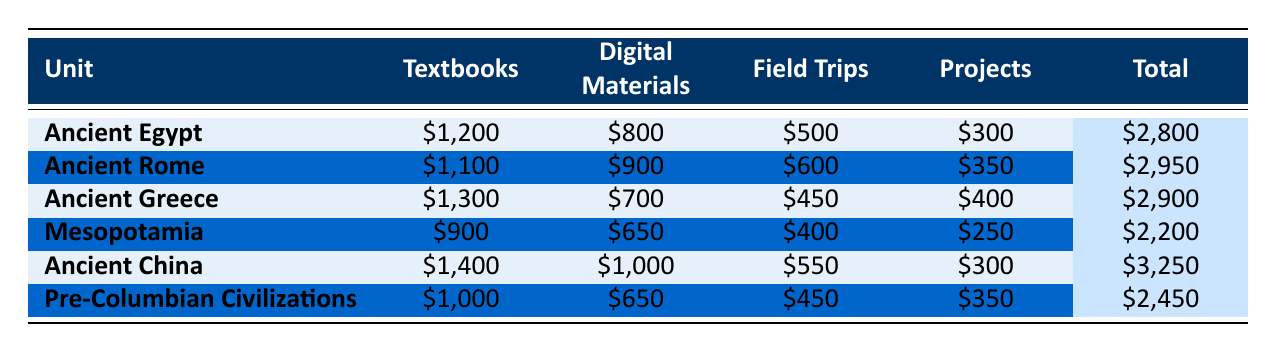What is the total budget allocated for Ancient Egypt? The total budget for Ancient Egypt is clearly stated in the table under the 'Total' column, which shows \$2,800.
Answer: \$2,800 Which unit has the highest budget allocation? By comparing the 'Total' values for each unit, Ancient China has the highest allocation of \$3,250.
Answer: Ancient China What is the total budget for textbooks across all units? To find the total for textbooks, sum the values in the 'Textbooks' column: 1200 + 1100 + 1300 + 900 + 1400 + 1000 = 6200.
Answer: \$6,200 Is the budget for Ancient Rome larger than that for Ancient Greece? By comparing the total budgets, Ancient Rome has \$2,950 while Ancient Greece has \$2,900, indicating that Ancient Rome's budget is larger.
Answer: Yes What is the difference in total budget between Ancient China and Mesopotamia? Subtract the total budget of Mesopotamia (\$2,200) from that of Ancient China (\$3,250): 3250 - 2200 = 1050.
Answer: \$1,050 What percentage of the total budget for Ancient Greece is allocated to digital materials? Calculate the percentage allocated to digital materials by taking the value for digital materials (\$700) and dividing by the total budget (\$2,900), then multiplying by 100: (700 / 2900) * 100 ≈ 24.14%.
Answer: 24.14% If the field trip budget for each unit were reduced by \$100, what would be the new total budget for Ancient Egypt? The original total budget for Ancient Egypt is \$2,800. Reducing the field trip budget by \$100 means subtracting that from the total: 2800 - 100 = 2700.
Answer: \$2,700 What is the average total budget allocated across all units? Add all total budgets: 2800 + 2950 + 2900 + 2200 + 3250 + 2450 = 16550, then divide by the number of units (6): 16550 / 6 = 2758.33.
Answer: \$2,758.33 Is the total budget for Pre-Columbian Civilizations lower than that for Mesopotamia? Comparing the total budgets, Pre-Columbian Civilizations has \$2,450 and Mesopotamia has \$2,200. Therefore, Pre-Columbian Civilizations is higher.
Answer: No Which two units have the closest total budget allocations? By examining the total budgets, Ancient Greece has \$2,900 and Ancient Rome has \$2,950, with only a \$50 difference, making them the closest.
Answer: Ancient Rome and Ancient Greece 